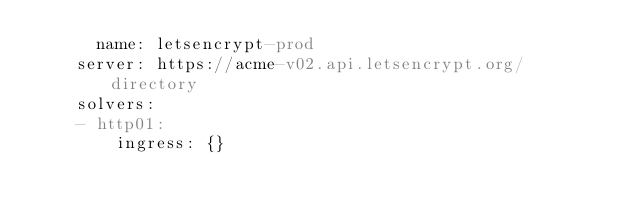Convert code to text. <code><loc_0><loc_0><loc_500><loc_500><_YAML_>      name: letsencrypt-prod
    server: https://acme-v02.api.letsencrypt.org/directory
    solvers:
    - http01:
        ingress: {}</code> 